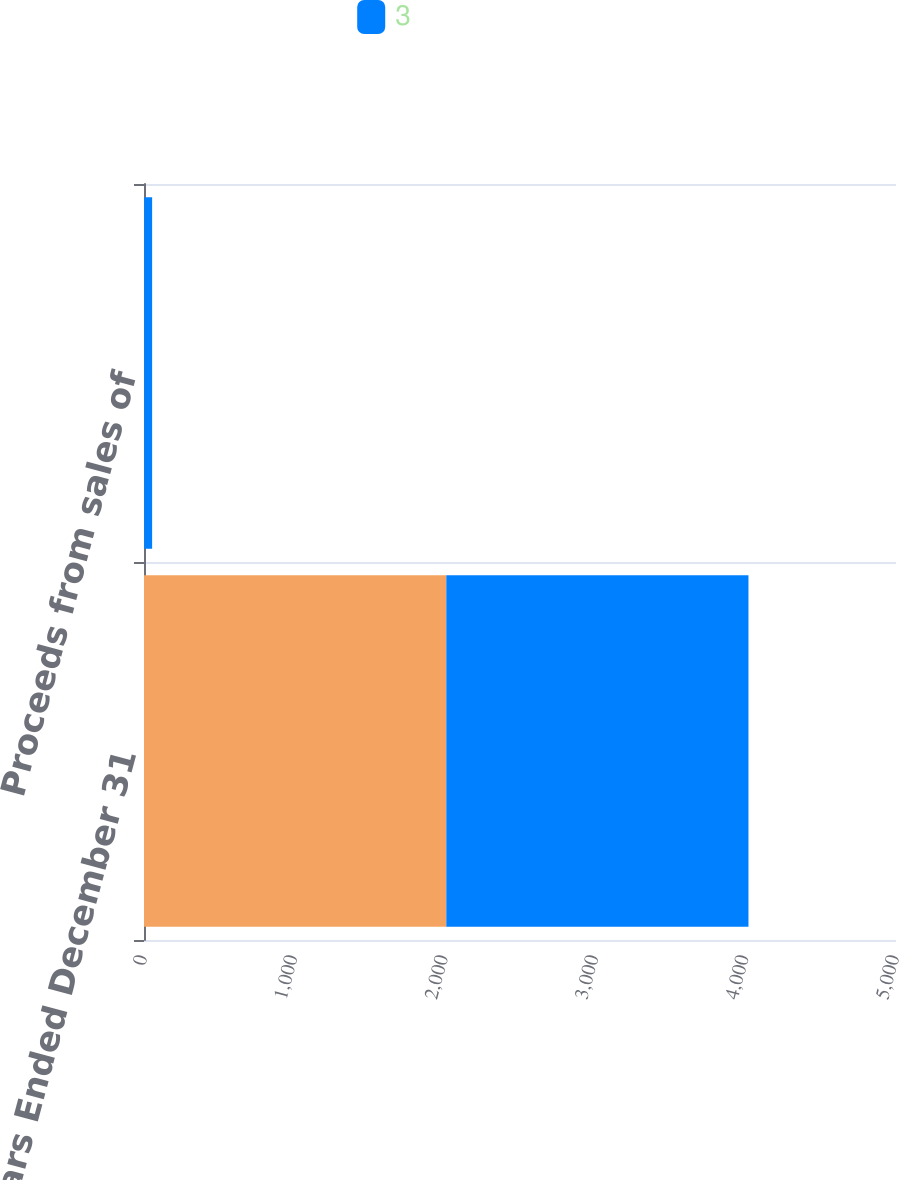<chart> <loc_0><loc_0><loc_500><loc_500><stacked_bar_chart><ecel><fcel>Years Ended December 31<fcel>Proceeds from sales of<nl><fcel>nan<fcel>2010<fcel>1<nl><fcel>3<fcel>2009<fcel>53<nl></chart> 